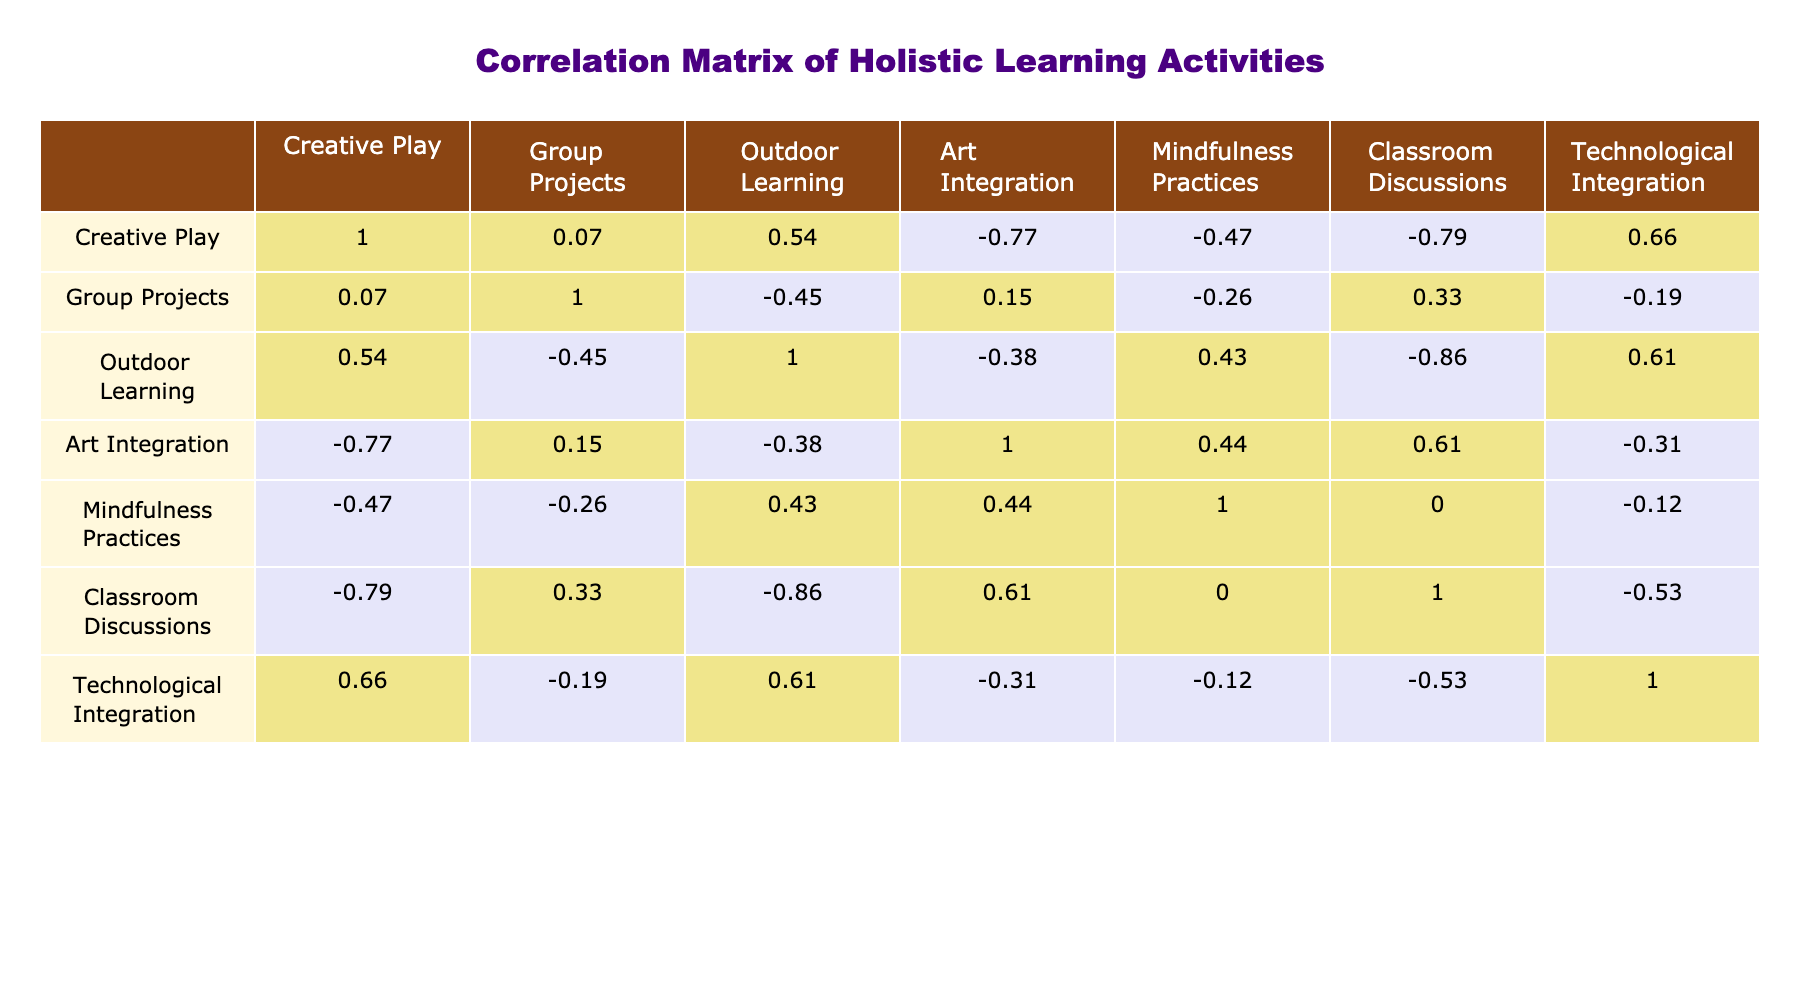What is the correlation between Creative Play and Emotional Support? From the table, we look at the row for Creative Play and the column for Emotional Support. The correlation value is 0.5, indicating a moderate positive correlation between these two variables.
Answer: 0.5 Which activity has the highest correlation with Student Engagement Level? By reviewing the correlations listed in the Student Engagement Level row, the highest correlation is with Group Projects, which shows a correlation of 0.9.
Answer: Group Projects Is there a correlation between Mindfulness Practices and Physical Activity? Checking the correlation value between Mindfulness Practices and Physical Activity, we find it is 0.2. This indicates a slight positive correlation.
Answer: Yes What is the average correlation between Holistic Learning and Teacher Involvement? First, we find the correlation values for Holistic Learning with Teacher Involvement, which is 0.8. Since there is only one value, the average is also 0.8.
Answer: 0.8 How does the correlation between Outdoor Learning and Student Collaboration compare to that of Art Integration and Student Engagement Level? The correlation of Outdoor Learning with Student Collaboration is 0.8, while Art Integration with Student Engagement Level is 0.6. Comparing, Outdoor Learning has a higher correlation with Student Collaboration than Art Integration has with Student Engagement Level.
Answer: Outdoor Learning has a higher correlation What is the correlation value for Technological Integration and Emotional Support? From the table, we see Technological Integration has a correlation value of 0.4 with Emotional Support.
Answer: 0.4 Is there no correlation between Creative Play and Critical Thinking? Checking the correlation between Creative Play (0.7) and Critical Thinking (0.6), they both possess positive correlation values, confirming that there is a correlation rather than none.
Answer: False How does the overall correlation of Group Projects with Emotional Support compare with that of Outdoor Learning with Teacher Involvement? The correlation for Group Projects and Emotional Support is 0.7, while for Outdoor Learning and Teacher Involvement, it is 0.8, indicating that Outdoor Learning has a stronger correlation with Teacher Involvement than Group Projects has with Emotional Support.
Answer: Outdoor Learning is stronger 